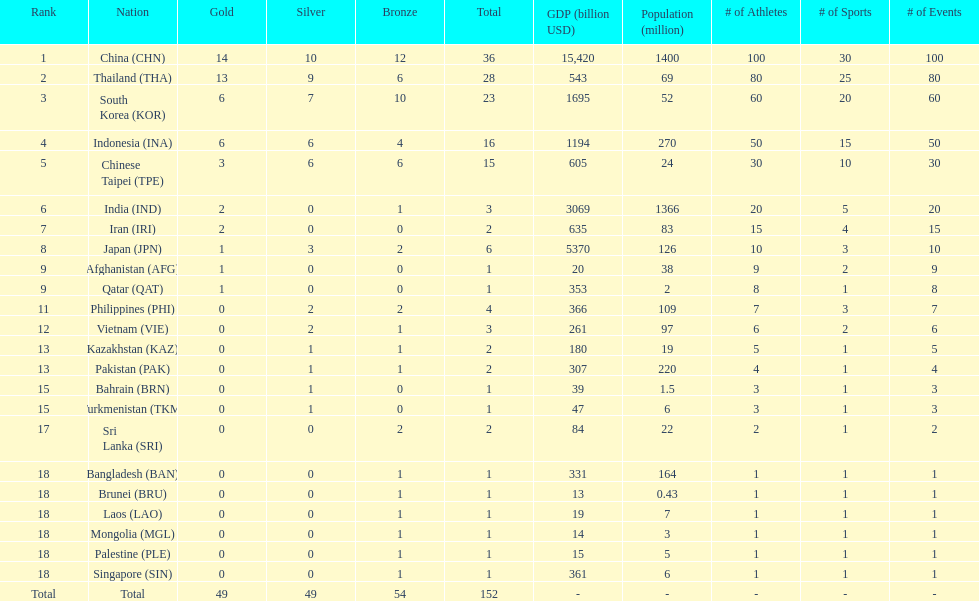How many nations won no silver medals at all? 11. 